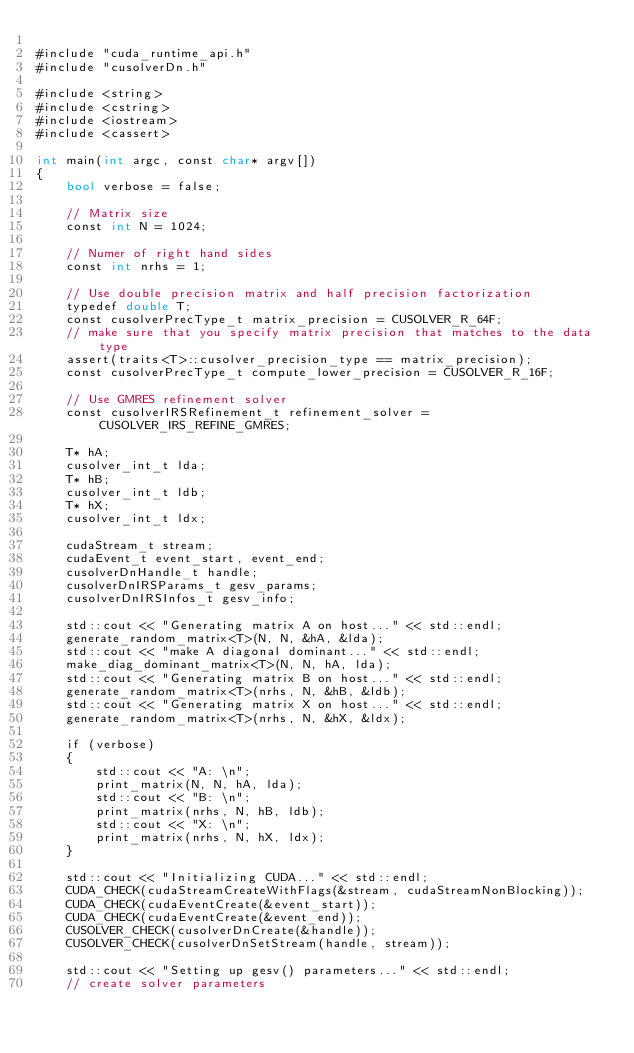<code> <loc_0><loc_0><loc_500><loc_500><_Cuda_>
#include "cuda_runtime_api.h"
#include "cusolverDn.h"

#include <string>
#include <cstring>
#include <iostream>
#include <cassert>

int main(int argc, const char* argv[])
{
    bool verbose = false;

    // Matrix size
    const int N = 1024;
    
    // Numer of right hand sides
    const int nrhs = 1;

    // Use double precision matrix and half precision factorization
    typedef double T;
    const cusolverPrecType_t matrix_precision = CUSOLVER_R_64F;
    // make sure that you specify matrix precision that matches to the data type
    assert(traits<T>::cusolver_precision_type == matrix_precision);
    const cusolverPrecType_t compute_lower_precision = CUSOLVER_R_16F;

    // Use GMRES refinement solver
    const cusolverIRSRefinement_t refinement_solver = CUSOLVER_IRS_REFINE_GMRES;

    T* hA;
    cusolver_int_t lda;
    T* hB;
    cusolver_int_t ldb;
    T* hX;
    cusolver_int_t ldx;

    cudaStream_t stream;
    cudaEvent_t event_start, event_end;
    cusolverDnHandle_t handle;
    cusolverDnIRSParams_t gesv_params;
    cusolverDnIRSInfos_t gesv_info;

    std::cout << "Generating matrix A on host..." << std::endl;
    generate_random_matrix<T>(N, N, &hA, &lda);
    std::cout << "make A diagonal dominant..." << std::endl;
    make_diag_dominant_matrix<T>(N, N, hA, lda);
    std::cout << "Generating matrix B on host..." << std::endl;
    generate_random_matrix<T>(nrhs, N, &hB, &ldb);
    std::cout << "Generating matrix X on host..." << std::endl;
    generate_random_matrix<T>(nrhs, N, &hX, &ldx);

    if (verbose)
    {
        std::cout << "A: \n";
        print_matrix(N, N, hA, lda);
        std::cout << "B: \n";
        print_matrix(nrhs, N, hB, ldb);
        std::cout << "X: \n";
        print_matrix(nrhs, N, hX, ldx);
    }

    std::cout << "Initializing CUDA..." << std::endl;
    CUDA_CHECK(cudaStreamCreateWithFlags(&stream, cudaStreamNonBlocking));
    CUDA_CHECK(cudaEventCreate(&event_start));
    CUDA_CHECK(cudaEventCreate(&event_end));
    CUSOLVER_CHECK(cusolverDnCreate(&handle));
    CUSOLVER_CHECK(cusolverDnSetStream(handle, stream));

    std::cout << "Setting up gesv() parameters..." << std::endl;
    // create solver parameters</code> 